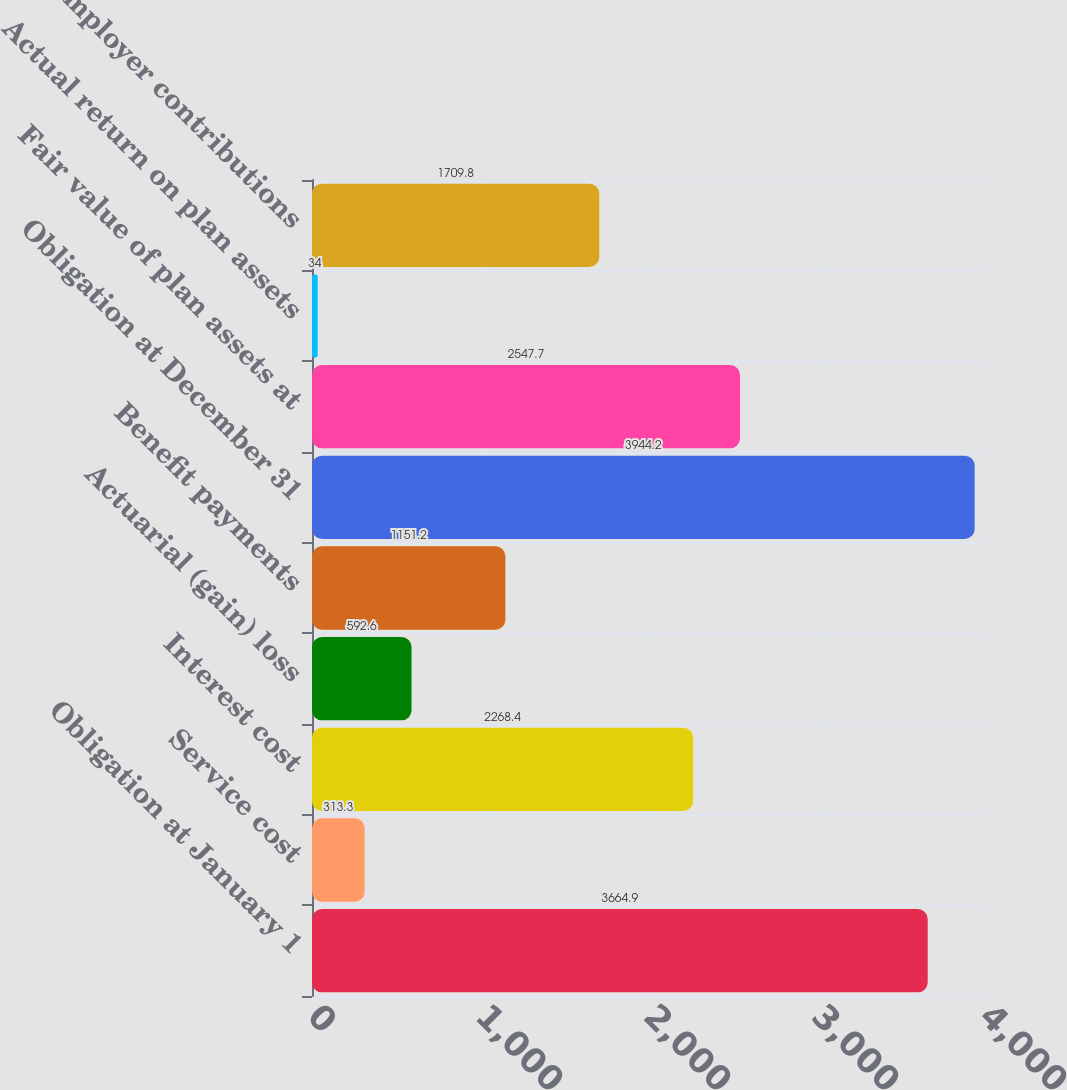Convert chart to OTSL. <chart><loc_0><loc_0><loc_500><loc_500><bar_chart><fcel>Obligation at January 1<fcel>Service cost<fcel>Interest cost<fcel>Actuarial (gain) loss<fcel>Benefit payments<fcel>Obligation at December 31<fcel>Fair value of plan assets at<fcel>Actual return on plan assets<fcel>Employer contributions<nl><fcel>3664.9<fcel>313.3<fcel>2268.4<fcel>592.6<fcel>1151.2<fcel>3944.2<fcel>2547.7<fcel>34<fcel>1709.8<nl></chart> 